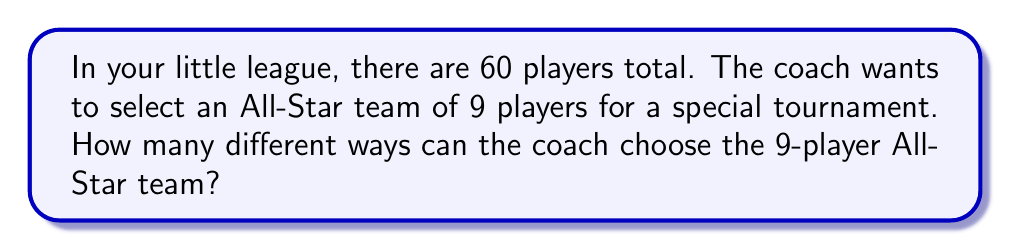Help me with this question. Let's approach this step-by-step:

1) This is a combination problem. We're selecting 9 players from a group of 60, where the order doesn't matter (it's just about who's on the team, not their positions).

2) We use the combination formula:

   $$C(n,r) = \frac{n!}{r!(n-r)!}$$

   Where $n$ is the total number of items to choose from, and $r$ is the number of items being chosen.

3) In this case, $n = 60$ (total players) and $r = 9$ (All-Star team size).

4) Plugging these numbers into our formula:

   $$C(60,9) = \frac{60!}{9!(60-9)!} = \frac{60!}{9!51!}$$

5) Calculating this:
   
   $$\frac{60 * 59 * 58 * 57 * 56 * 55 * 54 * 53 * 52 * 51!}{(9 * 8 * 7 * 6 * 5 * 4 * 3 * 2 * 1) * 51!}$$

6) The 51! cancels out in the numerator and denominator:

   $$\frac{60 * 59 * 58 * 57 * 56 * 55 * 54 * 53 * 52}{9 * 8 * 7 * 6 * 5 * 4 * 3 * 2 * 1}$$

7) Multiply the numerator and denominator:

   $$\frac{1.18699862 * 10^{17}}{362,880} = 327,160,515,720$$

Therefore, there are 327,160,515,720 different ways to select the All-Star team.
Answer: 327,160,515,720 